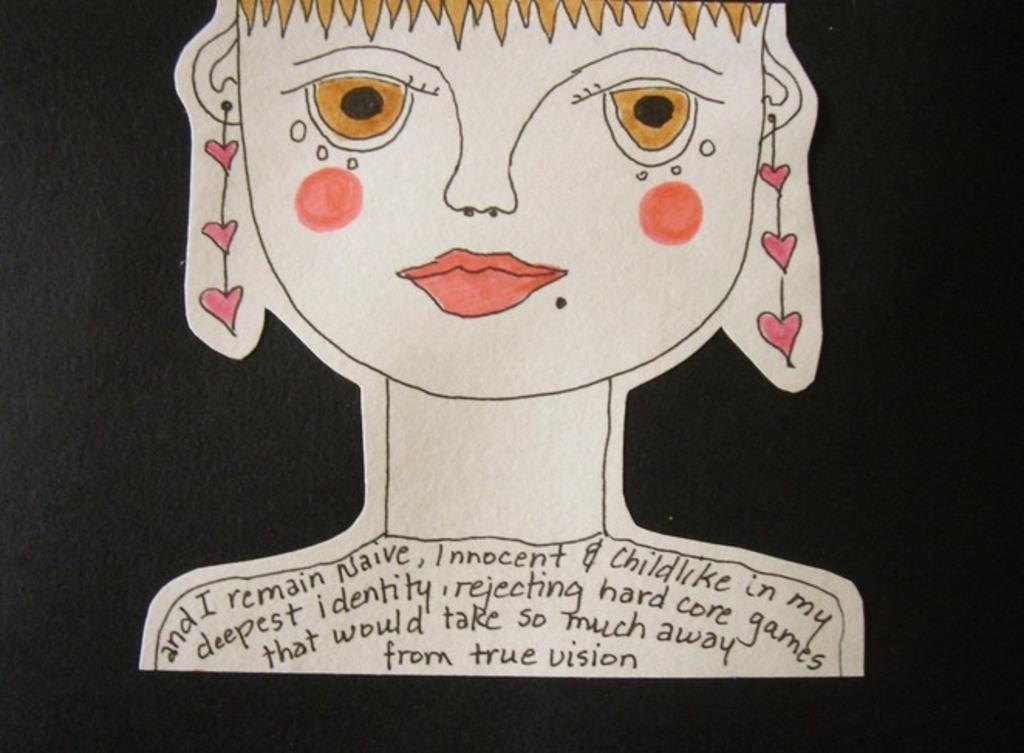What is the overall color scheme of the image? The background of the image is dark. What is the main subject of the image? There is a drawing of a girl in the image. What is written or depicted on the girl's shoulders? There is text on the girl's shoulders in the image. What cosmetic items are visible in the image? Lipstick and cheek shades are present in the image. What type of pickle is being used as a prop in the image? There is no pickle present in the image. What event is being depicted in the image? The image does not depict a specific event; it features a drawing of a girl with text on her shoulders and cosmetic items. 